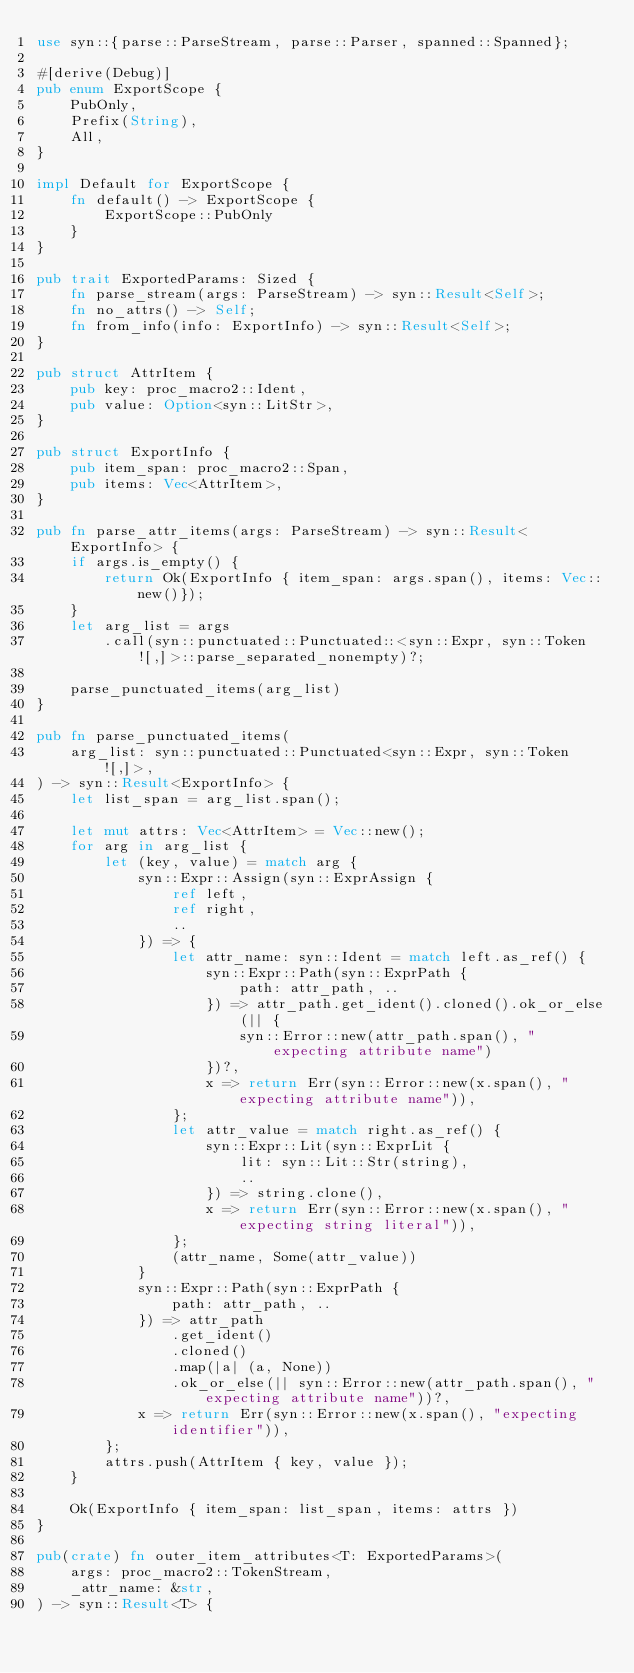<code> <loc_0><loc_0><loc_500><loc_500><_Rust_>use syn::{parse::ParseStream, parse::Parser, spanned::Spanned};

#[derive(Debug)]
pub enum ExportScope {
    PubOnly,
    Prefix(String),
    All,
}

impl Default for ExportScope {
    fn default() -> ExportScope {
        ExportScope::PubOnly
    }
}

pub trait ExportedParams: Sized {
    fn parse_stream(args: ParseStream) -> syn::Result<Self>;
    fn no_attrs() -> Self;
    fn from_info(info: ExportInfo) -> syn::Result<Self>;
}

pub struct AttrItem {
    pub key: proc_macro2::Ident,
    pub value: Option<syn::LitStr>,
}

pub struct ExportInfo {
    pub item_span: proc_macro2::Span,
    pub items: Vec<AttrItem>,
}

pub fn parse_attr_items(args: ParseStream) -> syn::Result<ExportInfo> {
    if args.is_empty() {
        return Ok(ExportInfo { item_span: args.span(), items: Vec::new()});
    }
    let arg_list = args
        .call(syn::punctuated::Punctuated::<syn::Expr, syn::Token![,]>::parse_separated_nonempty)?;

    parse_punctuated_items(arg_list)
}

pub fn parse_punctuated_items(
    arg_list: syn::punctuated::Punctuated<syn::Expr, syn::Token![,]>,
) -> syn::Result<ExportInfo> {
    let list_span = arg_list.span();

    let mut attrs: Vec<AttrItem> = Vec::new();
    for arg in arg_list {
        let (key, value) = match arg {
            syn::Expr::Assign(syn::ExprAssign {
                ref left,
                ref right,
                ..
            }) => {
                let attr_name: syn::Ident = match left.as_ref() {
                    syn::Expr::Path(syn::ExprPath {
                        path: attr_path, ..
                    }) => attr_path.get_ident().cloned().ok_or_else(|| {
                        syn::Error::new(attr_path.span(), "expecting attribute name")
                    })?,
                    x => return Err(syn::Error::new(x.span(), "expecting attribute name")),
                };
                let attr_value = match right.as_ref() {
                    syn::Expr::Lit(syn::ExprLit {
                        lit: syn::Lit::Str(string),
                        ..
                    }) => string.clone(),
                    x => return Err(syn::Error::new(x.span(), "expecting string literal")),
                };
                (attr_name, Some(attr_value))
            }
            syn::Expr::Path(syn::ExprPath {
                path: attr_path, ..
            }) => attr_path
                .get_ident()
                .cloned()
                .map(|a| (a, None))
                .ok_or_else(|| syn::Error::new(attr_path.span(), "expecting attribute name"))?,
            x => return Err(syn::Error::new(x.span(), "expecting identifier")),
        };
        attrs.push(AttrItem { key, value });
    }

    Ok(ExportInfo { item_span: list_span, items: attrs })
}

pub(crate) fn outer_item_attributes<T: ExportedParams>(
    args: proc_macro2::TokenStream,
    _attr_name: &str,
) -> syn::Result<T> {</code> 